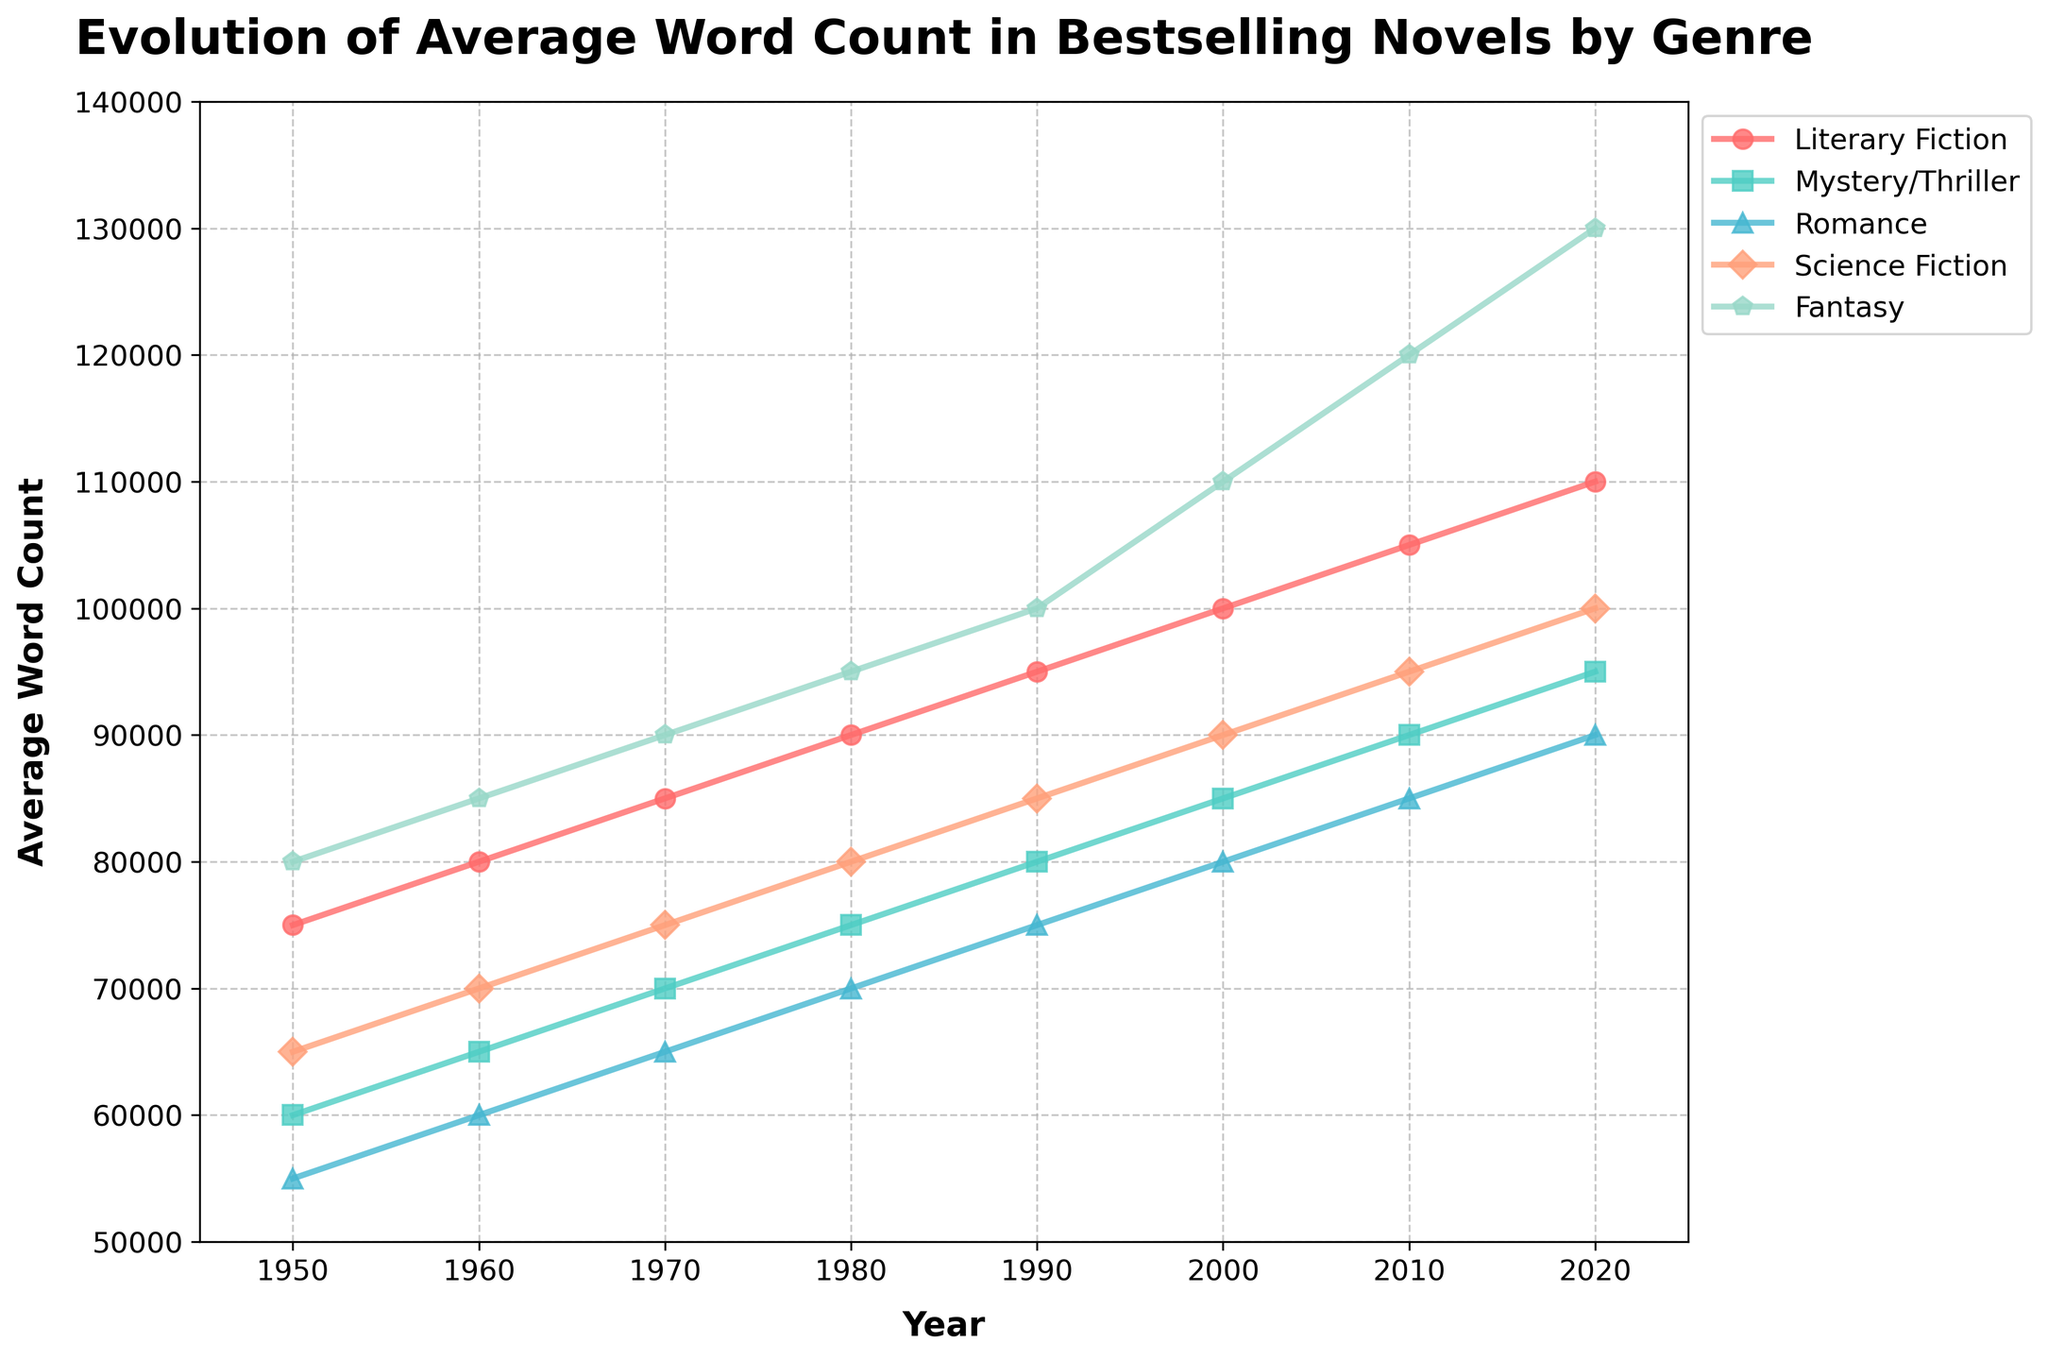What's the genre with the highest average word count in 2020? By examining the plot, we can see that in 2020, the genre with the highest average word count line has the highest position in 2020. The Fantasy genre has the highest average word count.
Answer: Fantasy How does the average word count of Literary Fiction in 1980 compare to Science Fiction in the same year? By locating 1980 on the x-axis and observing the two lines, we find that both Literary Fiction and Science Fiction have respective values of 90000 and 80000. Literary Fiction has a higher word count than Science Fiction by 10000 words.
Answer: Literary Fiction has 10000 more words Which genre shows the greatest increase in average word count from 1950 to 2020? To determine this, we need to calculate the difference in word counts between 1950 and 2020 for each genre. The changes are: 
Literary Fiction: 35000 (110000 - 75000)
Mystery/Thriller: 35000 (95000 - 60000)
Romance: 35000 (90000 - 55000)
Science Fiction: 35000 (100000 - 65000)
Fantasy: 50000 (130000 - 80000)
Comparing these values, Fantasy has the greatest increase.
Answer: Fantasy Compare the trend of average word counts between Romance and Science Fiction from 1950 to 2020. By observing the lines for Romance and Science Fiction, we can see that both lines steadily increase over time. Science Fiction has consistently higher average word counts than Romance in all years shown, and both genres have an upward trend.
Answer: Science Fiction consistently higher; both upward trends What is the difference between Fantasy's average word count and Mystery/Thriller's average word count in 2020? In 2020, the plot points for Fantasy and Mystery/Thriller give us respective values of 130000 and 95000. The difference is 130000 - 95000 = 35000.
Answer: 35000 Identify the year when Romance surpassed an average word count of 80000. Observing the Romance line, we find it surpasses 80000 in the year 2000.
Answer: 2000 What trend can be observed in the average word counts of Literary Fiction from 1950 to 2020? The line for Literary Fiction consistently increases from 75000 in 1950 to 110000 in 2020, indicating a steady upward trend over these years.
Answer: Steady upward trend Which genre had the smallest change in average word count between any two consecutive decades? By visually comparing the distances between points in consecutive decades for each genre, Romance had the least change between 2010 and 2020 where the change is only 5000 (90000 - 85000).
Answer: Romance (2010-2020) What is the average word count of Science Fiction over all the years provided? We need to average the Science Fiction word counts: (65000 + 70000 + 75000 + 80000 + 85000 + 90000 + 95000 + 100000) / 8 = 810000 / 8 = 101250.
Answer: 81250 